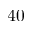Convert formula to latex. <formula><loc_0><loc_0><loc_500><loc_500>4 0</formula> 